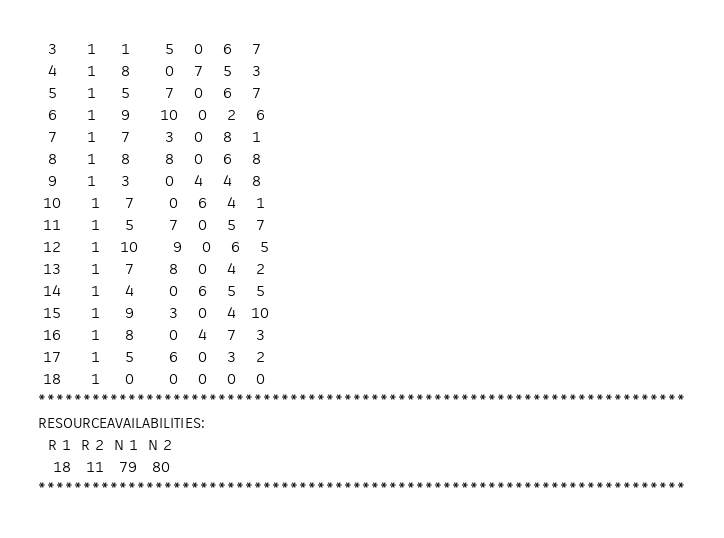Convert code to text. <code><loc_0><loc_0><loc_500><loc_500><_ObjectiveC_>  3      1     1       5    0    6    7
  4      1     8       0    7    5    3
  5      1     5       7    0    6    7
  6      1     9      10    0    2    6
  7      1     7       3    0    8    1
  8      1     8       8    0    6    8
  9      1     3       0    4    4    8
 10      1     7       0    6    4    1
 11      1     5       7    0    5    7
 12      1    10       9    0    6    5
 13      1     7       8    0    4    2
 14      1     4       0    6    5    5
 15      1     9       3    0    4   10
 16      1     8       0    4    7    3
 17      1     5       6    0    3    2
 18      1     0       0    0    0    0
************************************************************************
RESOURCEAVAILABILITIES:
  R 1  R 2  N 1  N 2
   18   11   79   80
************************************************************************
</code> 